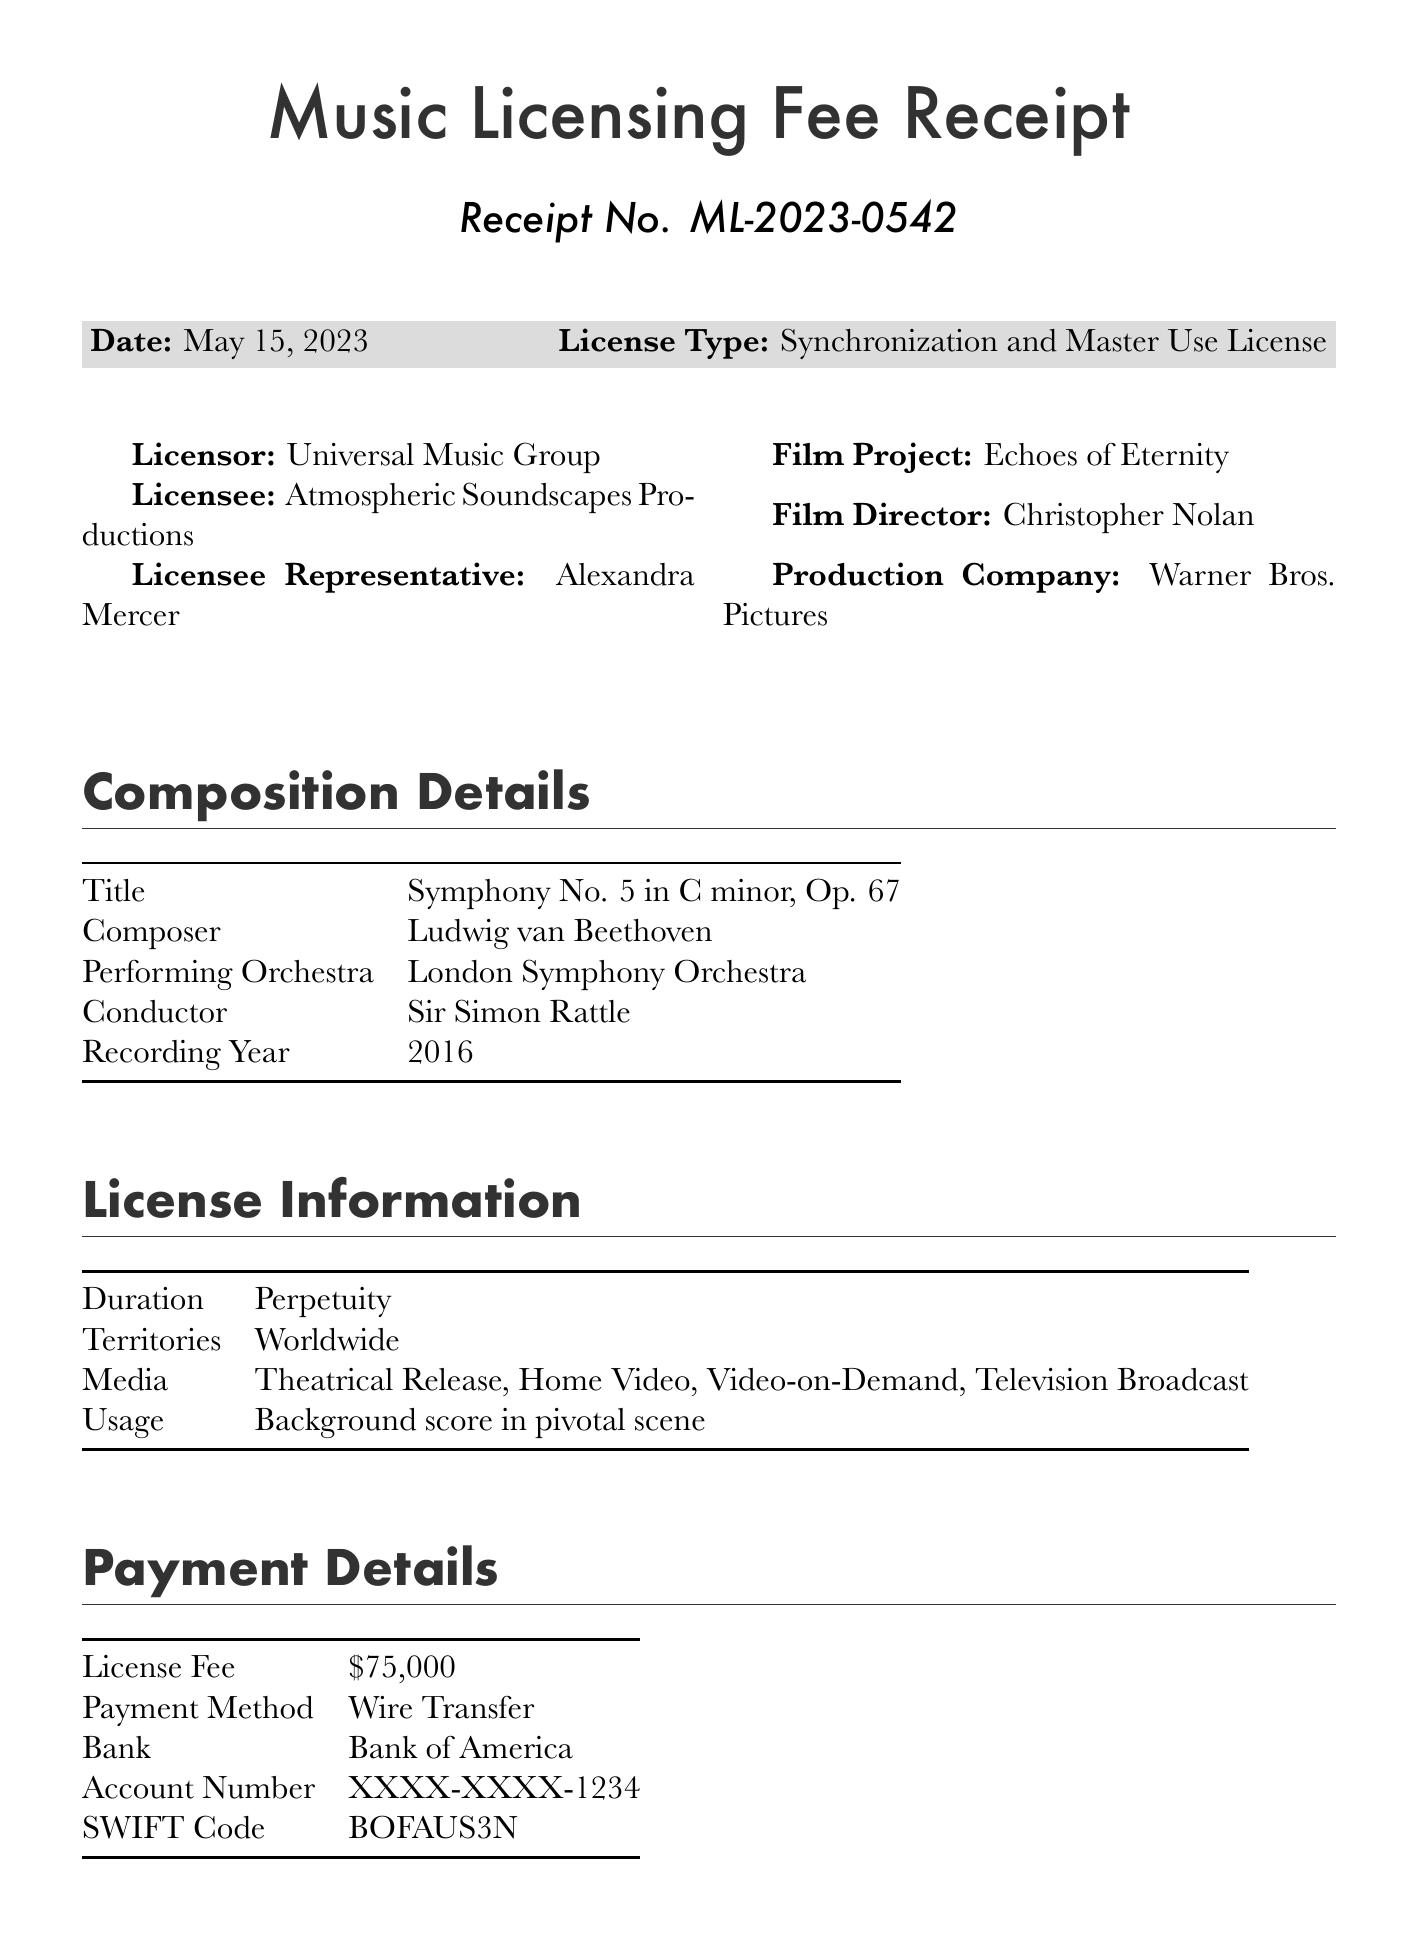what is the receipt number? The receipt number is a unique identifier for the document, specified as ML-2023-0542.
Answer: ML-2023-0542 who is the composer of the orchestral piece? The composer is a key detail in the composition section, which indicates Ludwig van Beethoven.
Answer: Ludwig van Beethoven what is the license fee? The license fee represents the cost associated with the licensing agreement, stated as $75,000.
Answer: $75,000 who is the licensee representative? This information identifies the person acting on behalf of the licensee, which is Alexandra Mercer.
Answer: Alexandra Mercer what is the duration of the license? The duration indicates how long the license is valid for, which is described as Perpetuity.
Answer: Perpetuity which orchestra performed the composition? This refers to the performing group that played the piece, specified as London Symphony Orchestra.
Answer: London Symphony Orchestra what media types are covered under this license? The media types indicate where the licensed music can be used, which includes theatrical release, home video, video-on-demand, and television broadcast.
Answer: Theatrical Release, Home Video, Video-on-Demand, Television Broadcast what does the terms and conditions state about alteration? This question focuses on a specific restriction in the terms, which clearly states that no alteration or remixing of the original composition is permitted.
Answer: No alteration or remixing of the original composition is permitted who is the authorized signatory for this receipt? The authorized signatory confirms who has the authority to sign the receipt, which is Michael Thompson.
Answer: Michael Thompson 